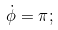Convert formula to latex. <formula><loc_0><loc_0><loc_500><loc_500>\dot { \phi } = \pi ;</formula> 